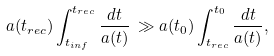<formula> <loc_0><loc_0><loc_500><loc_500>a ( t _ { r e c } ) \int _ { t _ { i n f } } ^ { t _ { r e c } } \frac { d t } { a ( t ) } \, \gg a ( t _ { 0 } ) \int _ { t _ { r e c } } ^ { t _ { 0 } } \frac { d t } { a ( t ) } ,</formula> 